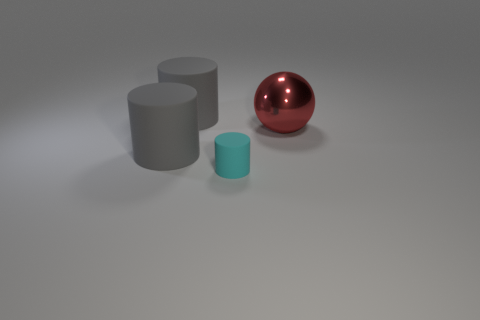Is there anything else that has the same size as the cyan rubber cylinder? Based on the scale in the image, there is no other object with dimensions that exactly match the cyan rubber cylinder's size. The other objects, which include a grey cylinder and a red sphere, exhibit different dimensions and proportions. 